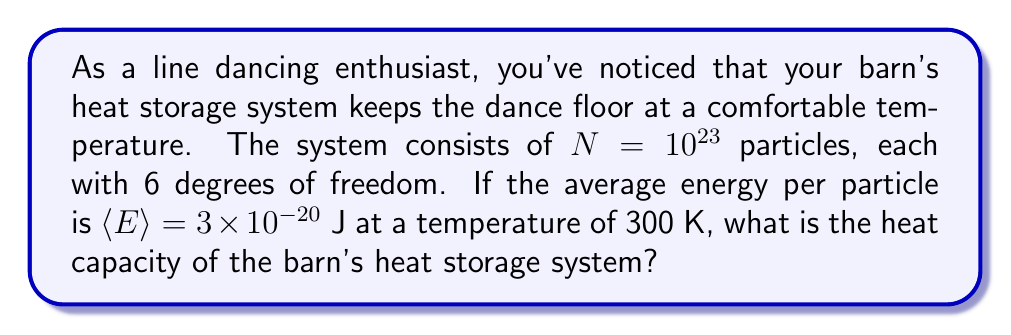Solve this math problem. Let's approach this step-by-step using statistical mechanics principles:

1) In classical statistical mechanics, the equipartition theorem states that each quadratic degree of freedom contributes $\frac{1}{2}k_B T$ to the average energy, where $k_B$ is the Boltzmann constant and $T$ is the temperature.

2) With 6 degrees of freedom per particle, the average energy per particle is:

   $\langle E \rangle = 6 \cdot \frac{1}{2}k_B T = 3k_B T$

3) We're given that $\langle E \rangle = 3 \times 10^{-20}$ J and $T = 300$ K. Let's use this to find $k_B$:

   $3 \times 10^{-20} = 3k_B \cdot 300$
   $k_B = \frac{3 \times 10^{-20}}{900} = 3.33 \times 10^{-23}$ J/K

4) The total energy of the system is:

   $E_{total} = N \langle E \rangle = 10^{23} \cdot 3 \times 10^{-20} = 3 \times 10^3$ J

5) The heat capacity $C$ is defined as the change in energy with respect to temperature:

   $C = \frac{\partial E}{\partial T}$

6) From step 2, we know that $E = 3Nk_B T$. Taking the derivative:

   $C = \frac{\partial (3Nk_B T)}{\partial T} = 3Nk_B$

7) Substituting the values:

   $C = 3 \cdot 10^{23} \cdot 3.33 \times 10^{-23} = 9.99 \times 10^0$ J/K

Therefore, the heat capacity of the barn's heat storage system is approximately 10 J/K.
Answer: 10 J/K 